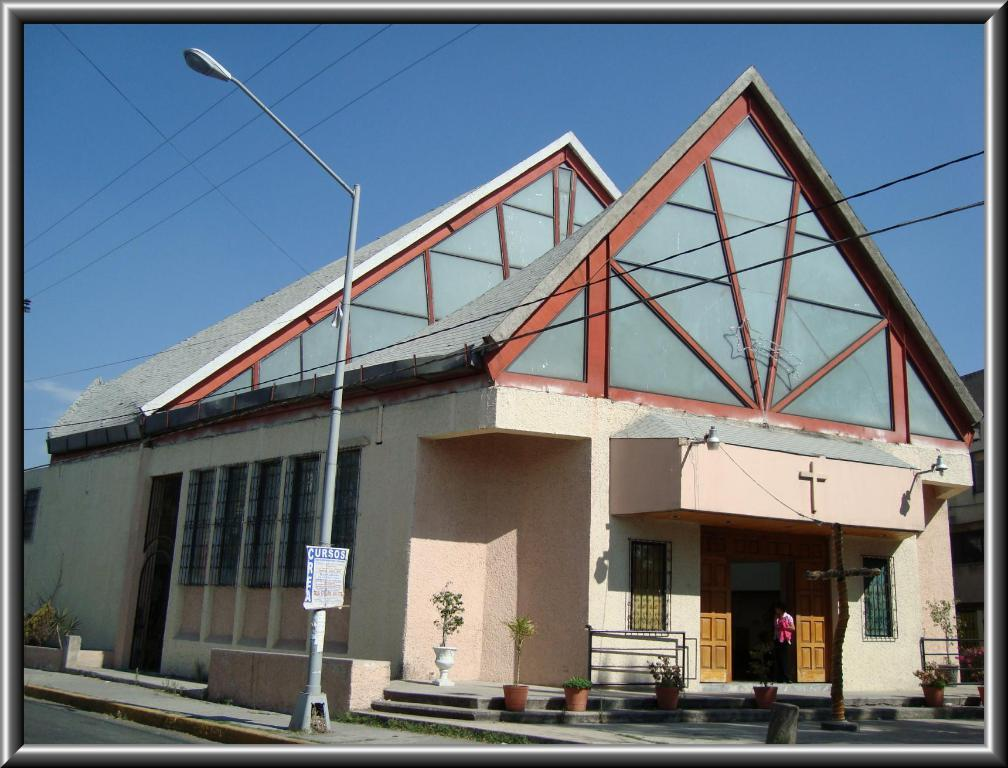What type of structure is present in the image? There is a street light in the image. What other type of structure can be seen in the image? There is a house in the image. What is visible at the top of the image? The sky is visible at the top of the image. What type of blade is attached to the street light in the image? There is no blade attached to the street light in the image. What color is the thread used to decorate the house in the image? There is no thread used to decorate the house in the image. 